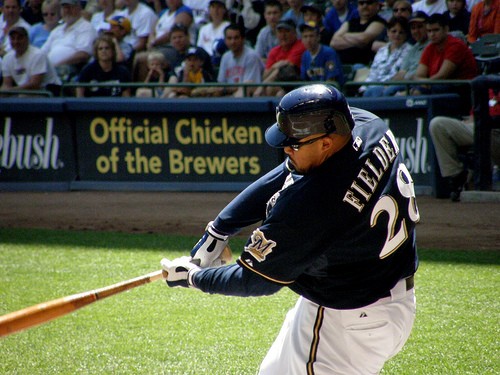Identify the text contained in this image. Official Chicken Brewers the Of M ish 28 FIELDER bush 